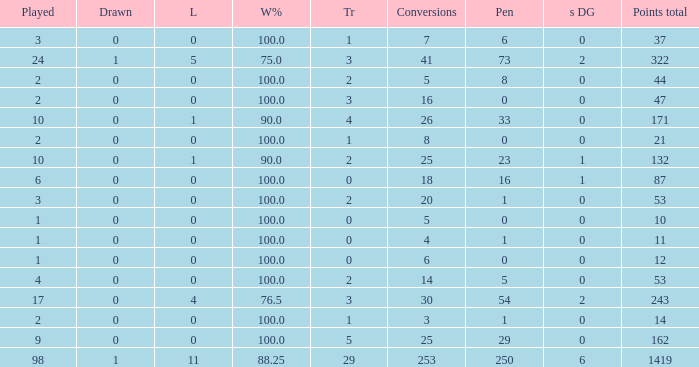What is the least number of penalties he got when his point total was over 1419 in more than 98 games? None. 